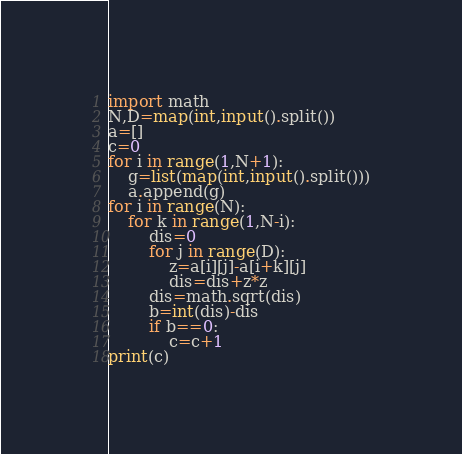<code> <loc_0><loc_0><loc_500><loc_500><_Python_>import math
N,D=map(int,input().split())
a=[]
c=0
for i in range(1,N+1):
    g=list(map(int,input().split()))
    a.append(g)
for i in range(N):
    for k in range(1,N-i):
        dis=0
        for j in range(D):
            z=a[i][j]-a[i+k][j]
            dis=dis+z*z
        dis=math.sqrt(dis)
        b=int(dis)-dis
        if b==0:
            c=c+1
print(c)</code> 